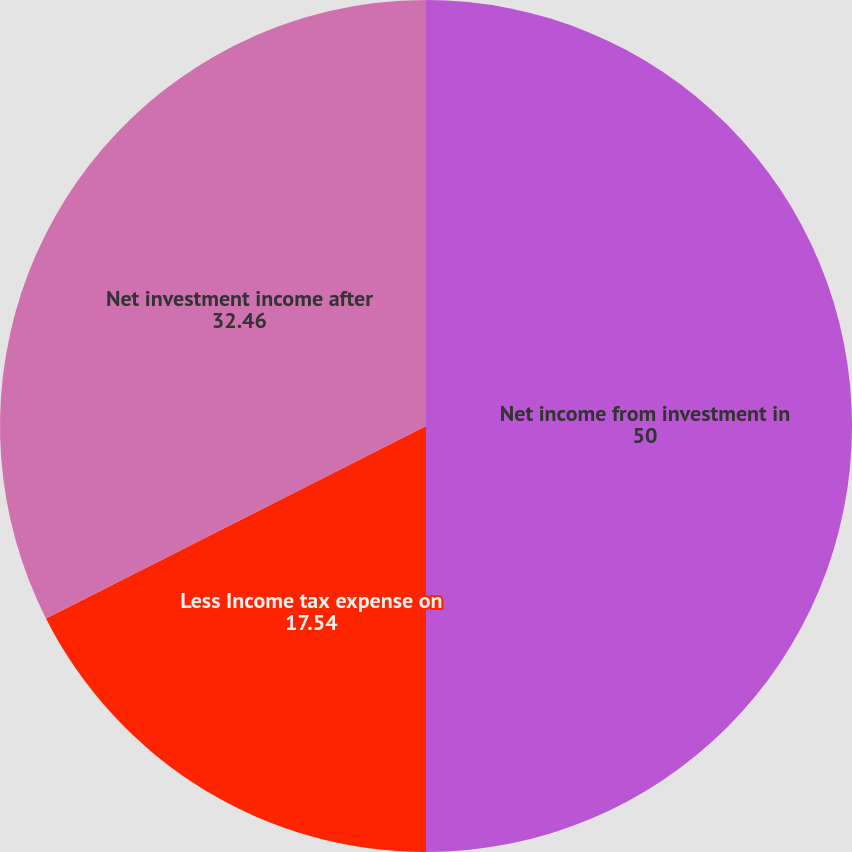<chart> <loc_0><loc_0><loc_500><loc_500><pie_chart><fcel>Net income from investment in<fcel>Less Income tax expense on<fcel>Net investment income after<nl><fcel>50.0%<fcel>17.54%<fcel>32.46%<nl></chart> 